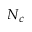Convert formula to latex. <formula><loc_0><loc_0><loc_500><loc_500>N _ { c }</formula> 